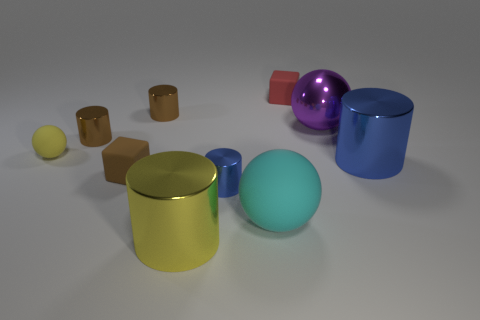What number of tiny objects are blue cylinders or red cubes?
Offer a very short reply. 2. Are there more large yellow metal cylinders than small cyan metallic cylinders?
Offer a very short reply. Yes. There is a big metallic object that is behind the blue cylinder that is behind the brown rubber object; how many yellow matte spheres are on the right side of it?
Your answer should be very brief. 0. The tiny blue object is what shape?
Your response must be concise. Cylinder. How many other objects are there of the same material as the yellow cylinder?
Keep it short and to the point. 5. Is the size of the yellow shiny cylinder the same as the yellow rubber ball?
Offer a very short reply. No. There is a large object that is on the left side of the large rubber sphere; what is its shape?
Provide a succinct answer. Cylinder. What color is the small shiny cylinder that is in front of the big cylinder that is to the right of the yellow metal cylinder?
Your answer should be compact. Blue. There is a blue thing right of the small red cube; is its shape the same as the brown object in front of the yellow matte ball?
Your response must be concise. No. There is a yellow thing that is the same size as the red rubber block; what is its shape?
Give a very brief answer. Sphere. 